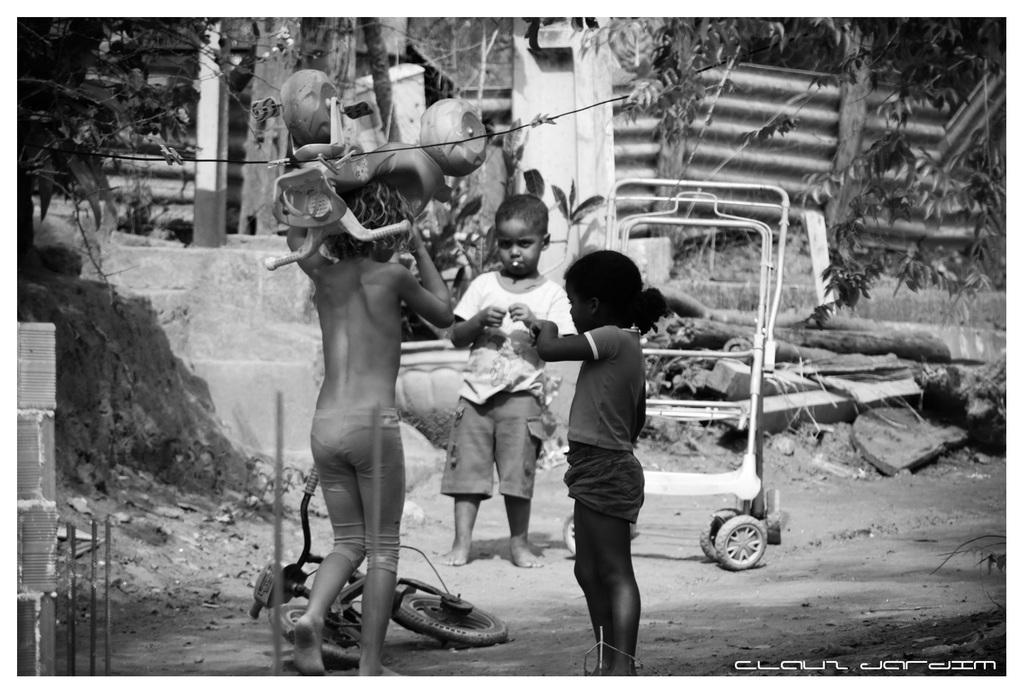Who is present in the image? There are children in the image. What objects are on the ground in the image? There is a bicycle and a trolley on the ground in the image. What can be seen in the background of the image? There are trees, a roof sheet, and other objects visible in the background of the image. What type of notebook is being used by the children in the image? There is no notebook present in the image; the children are not shown using any notebooks. 